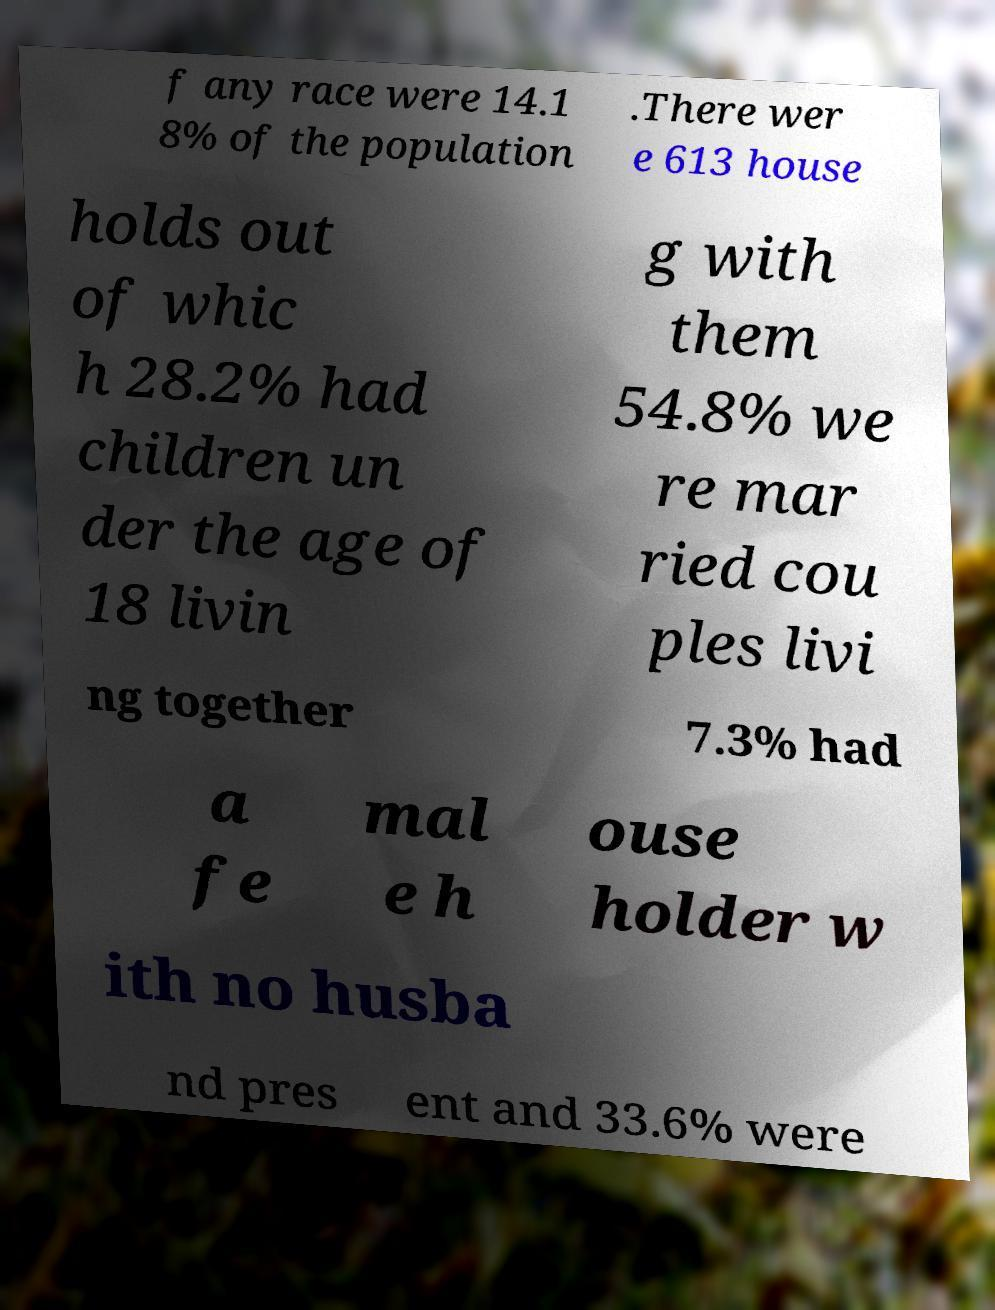What messages or text are displayed in this image? I need them in a readable, typed format. f any race were 14.1 8% of the population .There wer e 613 house holds out of whic h 28.2% had children un der the age of 18 livin g with them 54.8% we re mar ried cou ples livi ng together 7.3% had a fe mal e h ouse holder w ith no husba nd pres ent and 33.6% were 